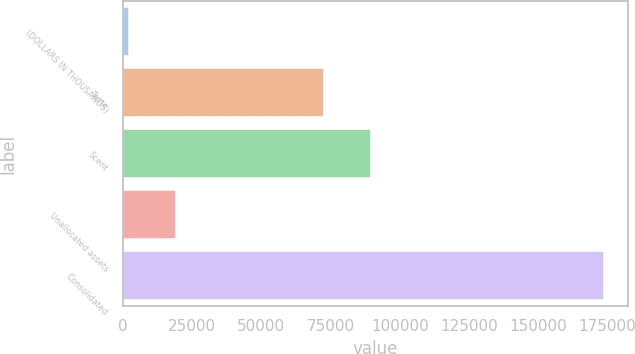<chart> <loc_0><loc_0><loc_500><loc_500><bar_chart><fcel>(DOLLARS IN THOUSANDS)<fcel>Taste<fcel>Scent<fcel>Unallocated assets<fcel>Consolidated<nl><fcel>2018<fcel>72474<fcel>89651.4<fcel>19195.4<fcel>173792<nl></chart> 